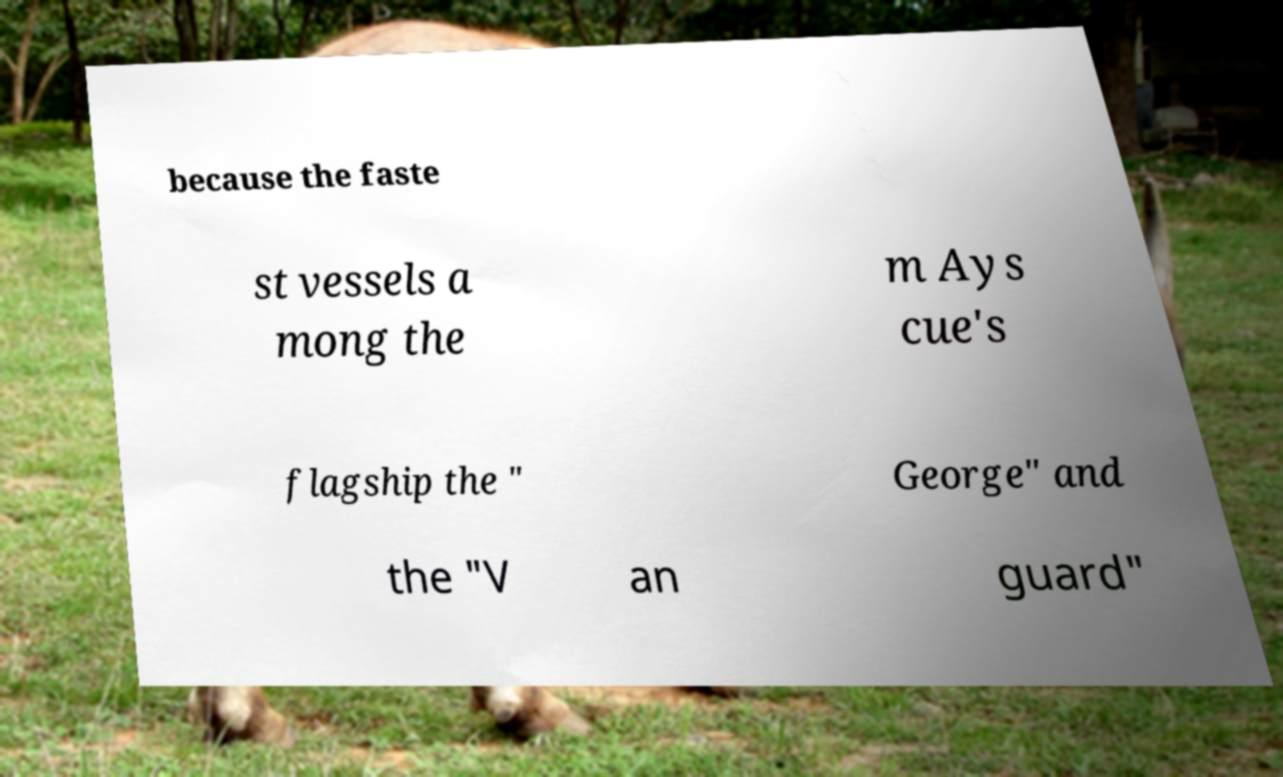Could you assist in decoding the text presented in this image and type it out clearly? because the faste st vessels a mong the m Ays cue's flagship the " George" and the "V an guard" 